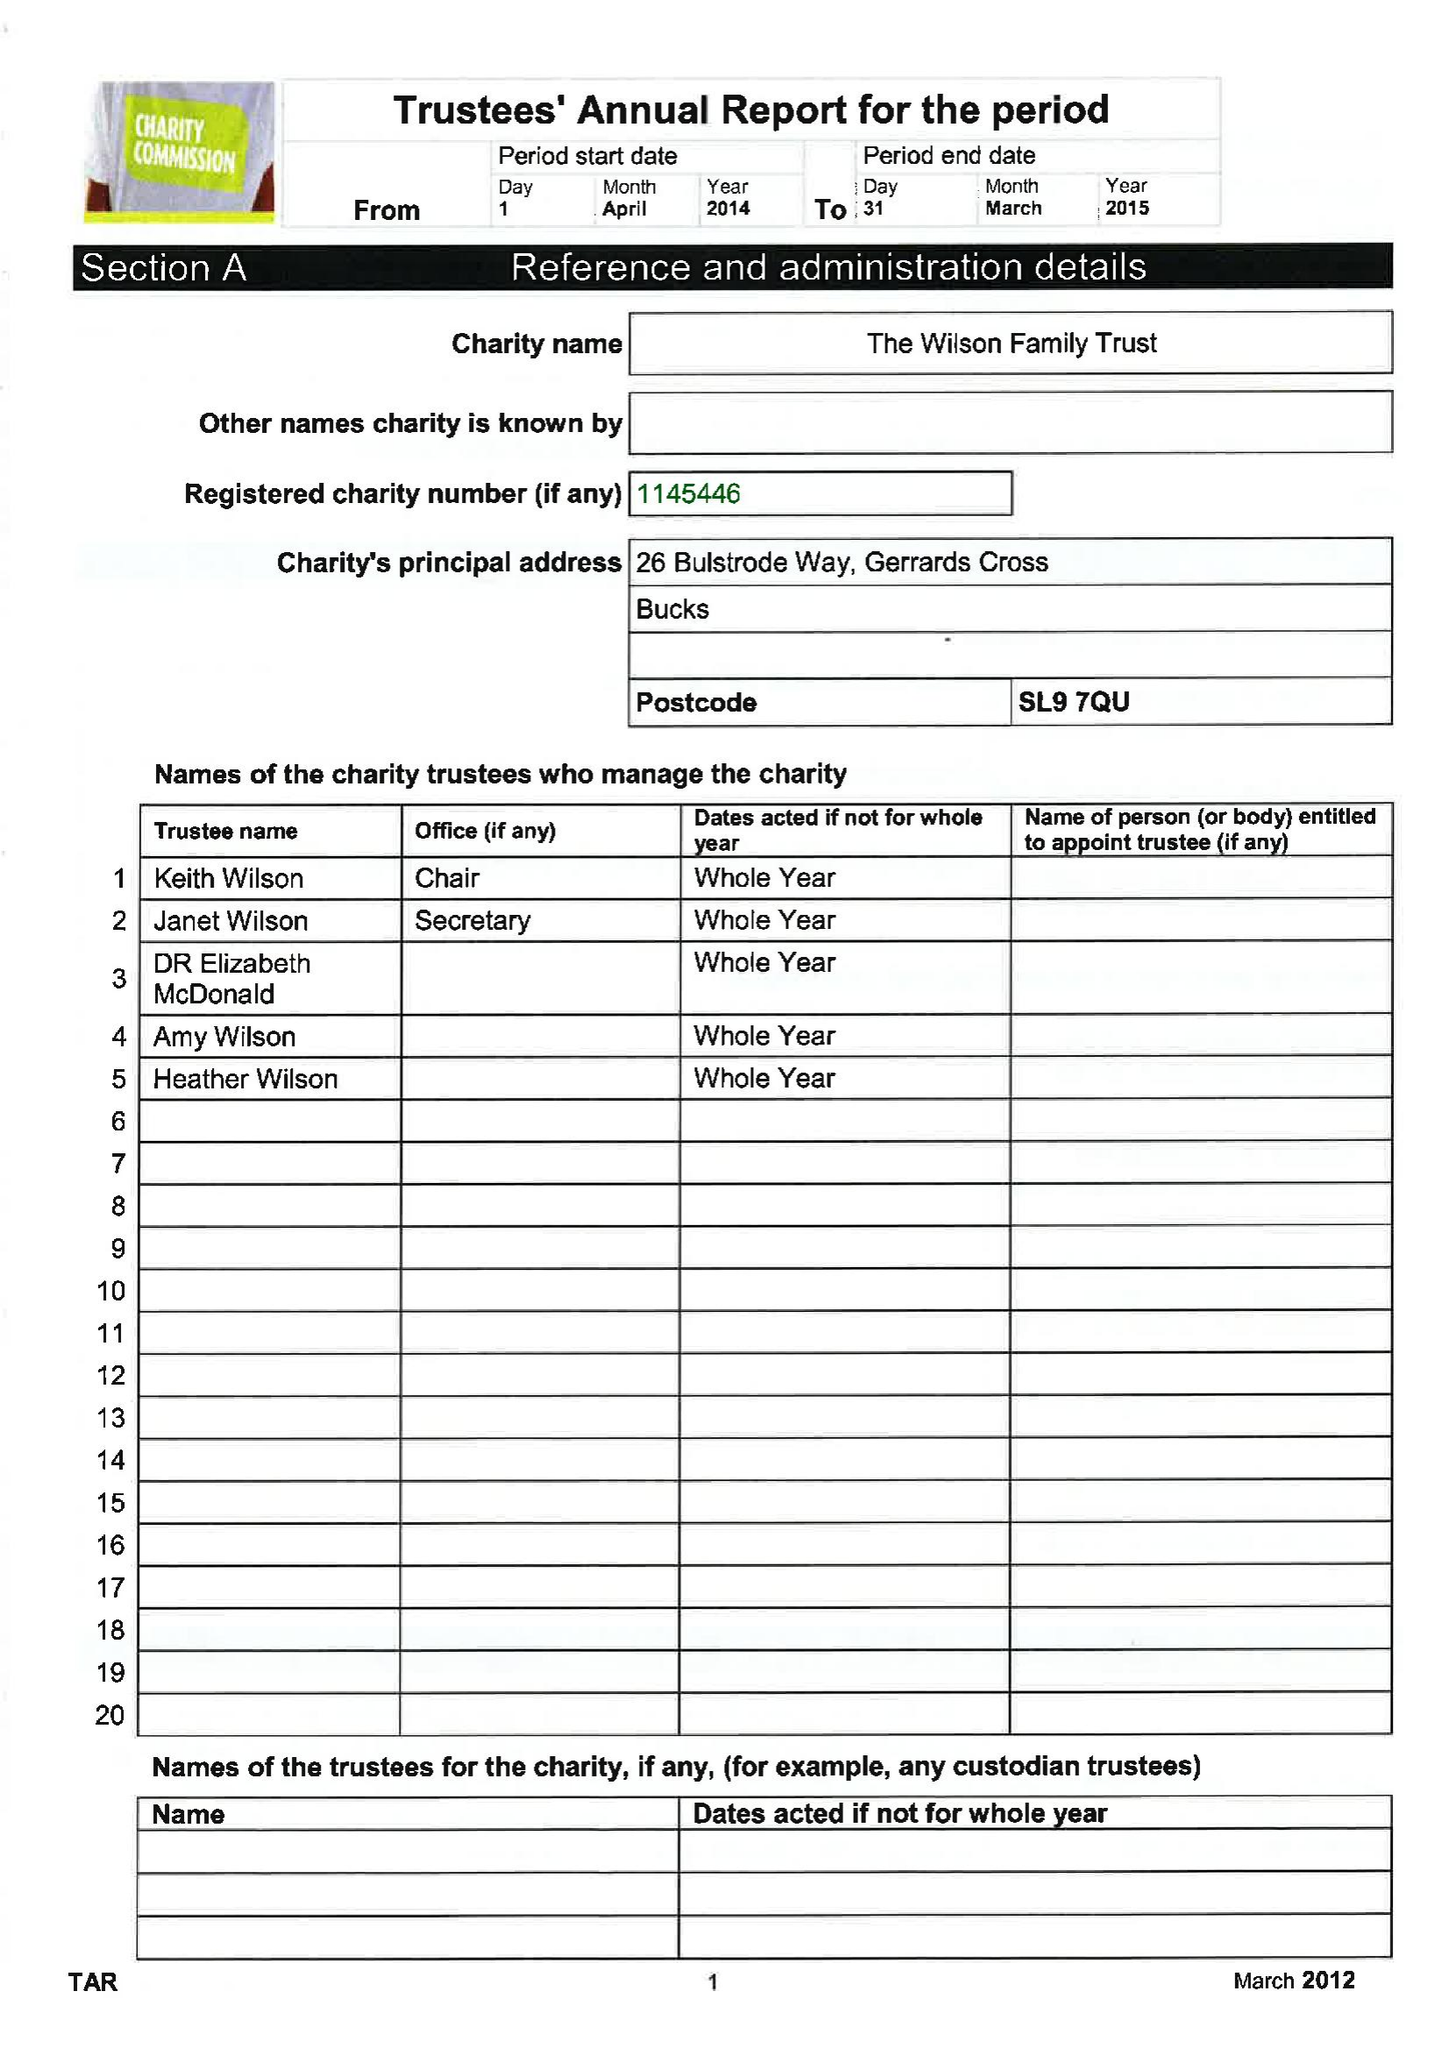What is the value for the charity_number?
Answer the question using a single word or phrase. 1145446 